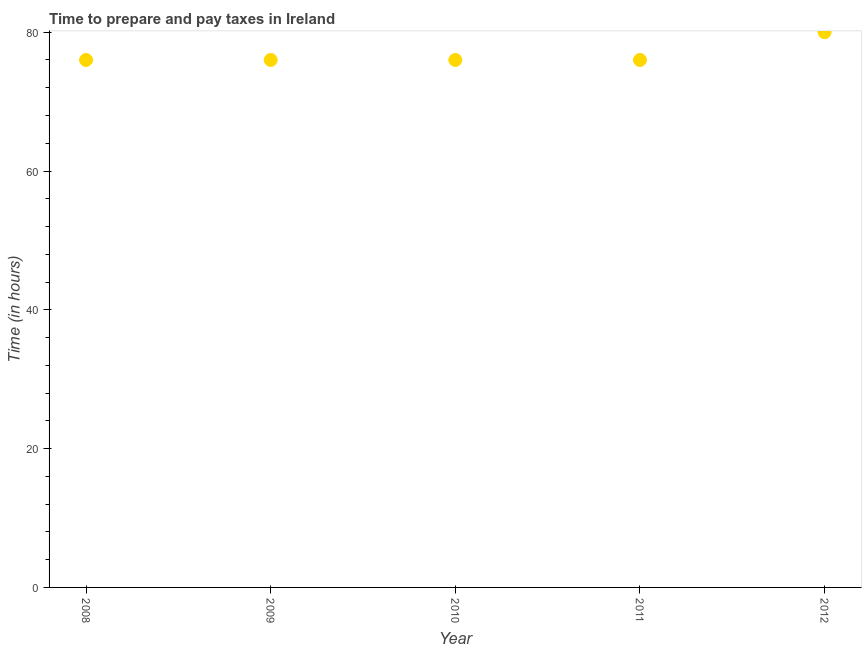What is the time to prepare and pay taxes in 2008?
Your response must be concise. 76. Across all years, what is the maximum time to prepare and pay taxes?
Provide a succinct answer. 80. Across all years, what is the minimum time to prepare and pay taxes?
Offer a terse response. 76. In which year was the time to prepare and pay taxes maximum?
Give a very brief answer. 2012. In which year was the time to prepare and pay taxes minimum?
Ensure brevity in your answer.  2008. What is the sum of the time to prepare and pay taxes?
Provide a short and direct response. 384. What is the difference between the time to prepare and pay taxes in 2011 and 2012?
Your response must be concise. -4. What is the average time to prepare and pay taxes per year?
Provide a succinct answer. 76.8. What is the median time to prepare and pay taxes?
Provide a short and direct response. 76. Is the time to prepare and pay taxes in 2009 less than that in 2010?
Your answer should be very brief. No. Is the difference between the time to prepare and pay taxes in 2009 and 2011 greater than the difference between any two years?
Your answer should be very brief. No. What is the difference between the highest and the second highest time to prepare and pay taxes?
Keep it short and to the point. 4. What is the difference between the highest and the lowest time to prepare and pay taxes?
Ensure brevity in your answer.  4. In how many years, is the time to prepare and pay taxes greater than the average time to prepare and pay taxes taken over all years?
Your response must be concise. 1. Does the time to prepare and pay taxes monotonically increase over the years?
Provide a short and direct response. No. Does the graph contain any zero values?
Provide a short and direct response. No. Does the graph contain grids?
Ensure brevity in your answer.  No. What is the title of the graph?
Your answer should be very brief. Time to prepare and pay taxes in Ireland. What is the label or title of the X-axis?
Your response must be concise. Year. What is the label or title of the Y-axis?
Provide a succinct answer. Time (in hours). What is the Time (in hours) in 2011?
Provide a succinct answer. 76. What is the difference between the Time (in hours) in 2008 and 2009?
Provide a short and direct response. 0. What is the difference between the Time (in hours) in 2008 and 2010?
Provide a succinct answer. 0. What is the difference between the Time (in hours) in 2010 and 2011?
Offer a terse response. 0. What is the ratio of the Time (in hours) in 2008 to that in 2011?
Give a very brief answer. 1. What is the ratio of the Time (in hours) in 2008 to that in 2012?
Provide a succinct answer. 0.95. What is the ratio of the Time (in hours) in 2009 to that in 2011?
Your answer should be compact. 1. What is the ratio of the Time (in hours) in 2009 to that in 2012?
Your answer should be very brief. 0.95. What is the ratio of the Time (in hours) in 2010 to that in 2012?
Provide a short and direct response. 0.95. 